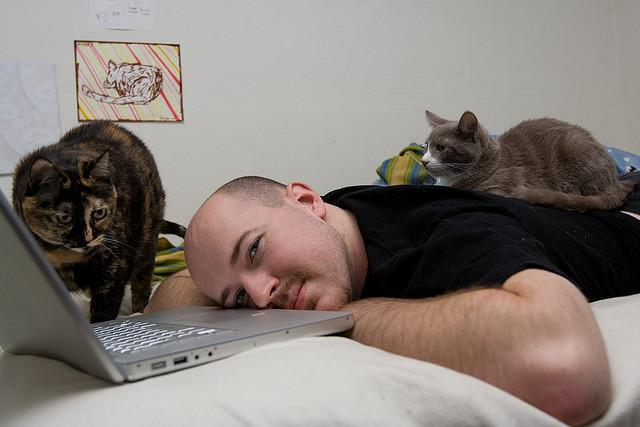How many mammals area shown? three 